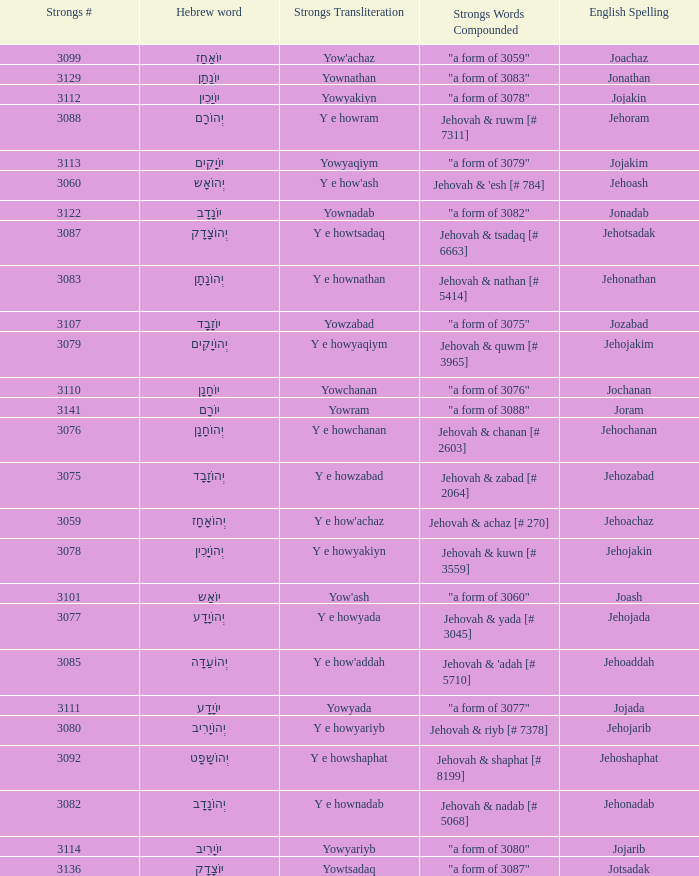What is the strongs words compounded when the english spelling is jonadab? "a form of 3082". 